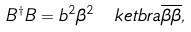Convert formula to latex. <formula><loc_0><loc_0><loc_500><loc_500>B ^ { \dagger } B = b ^ { 2 } \beta ^ { 2 } \, \ k e t b r a { \overline { \beta } } { \overline { \beta } } ,</formula> 